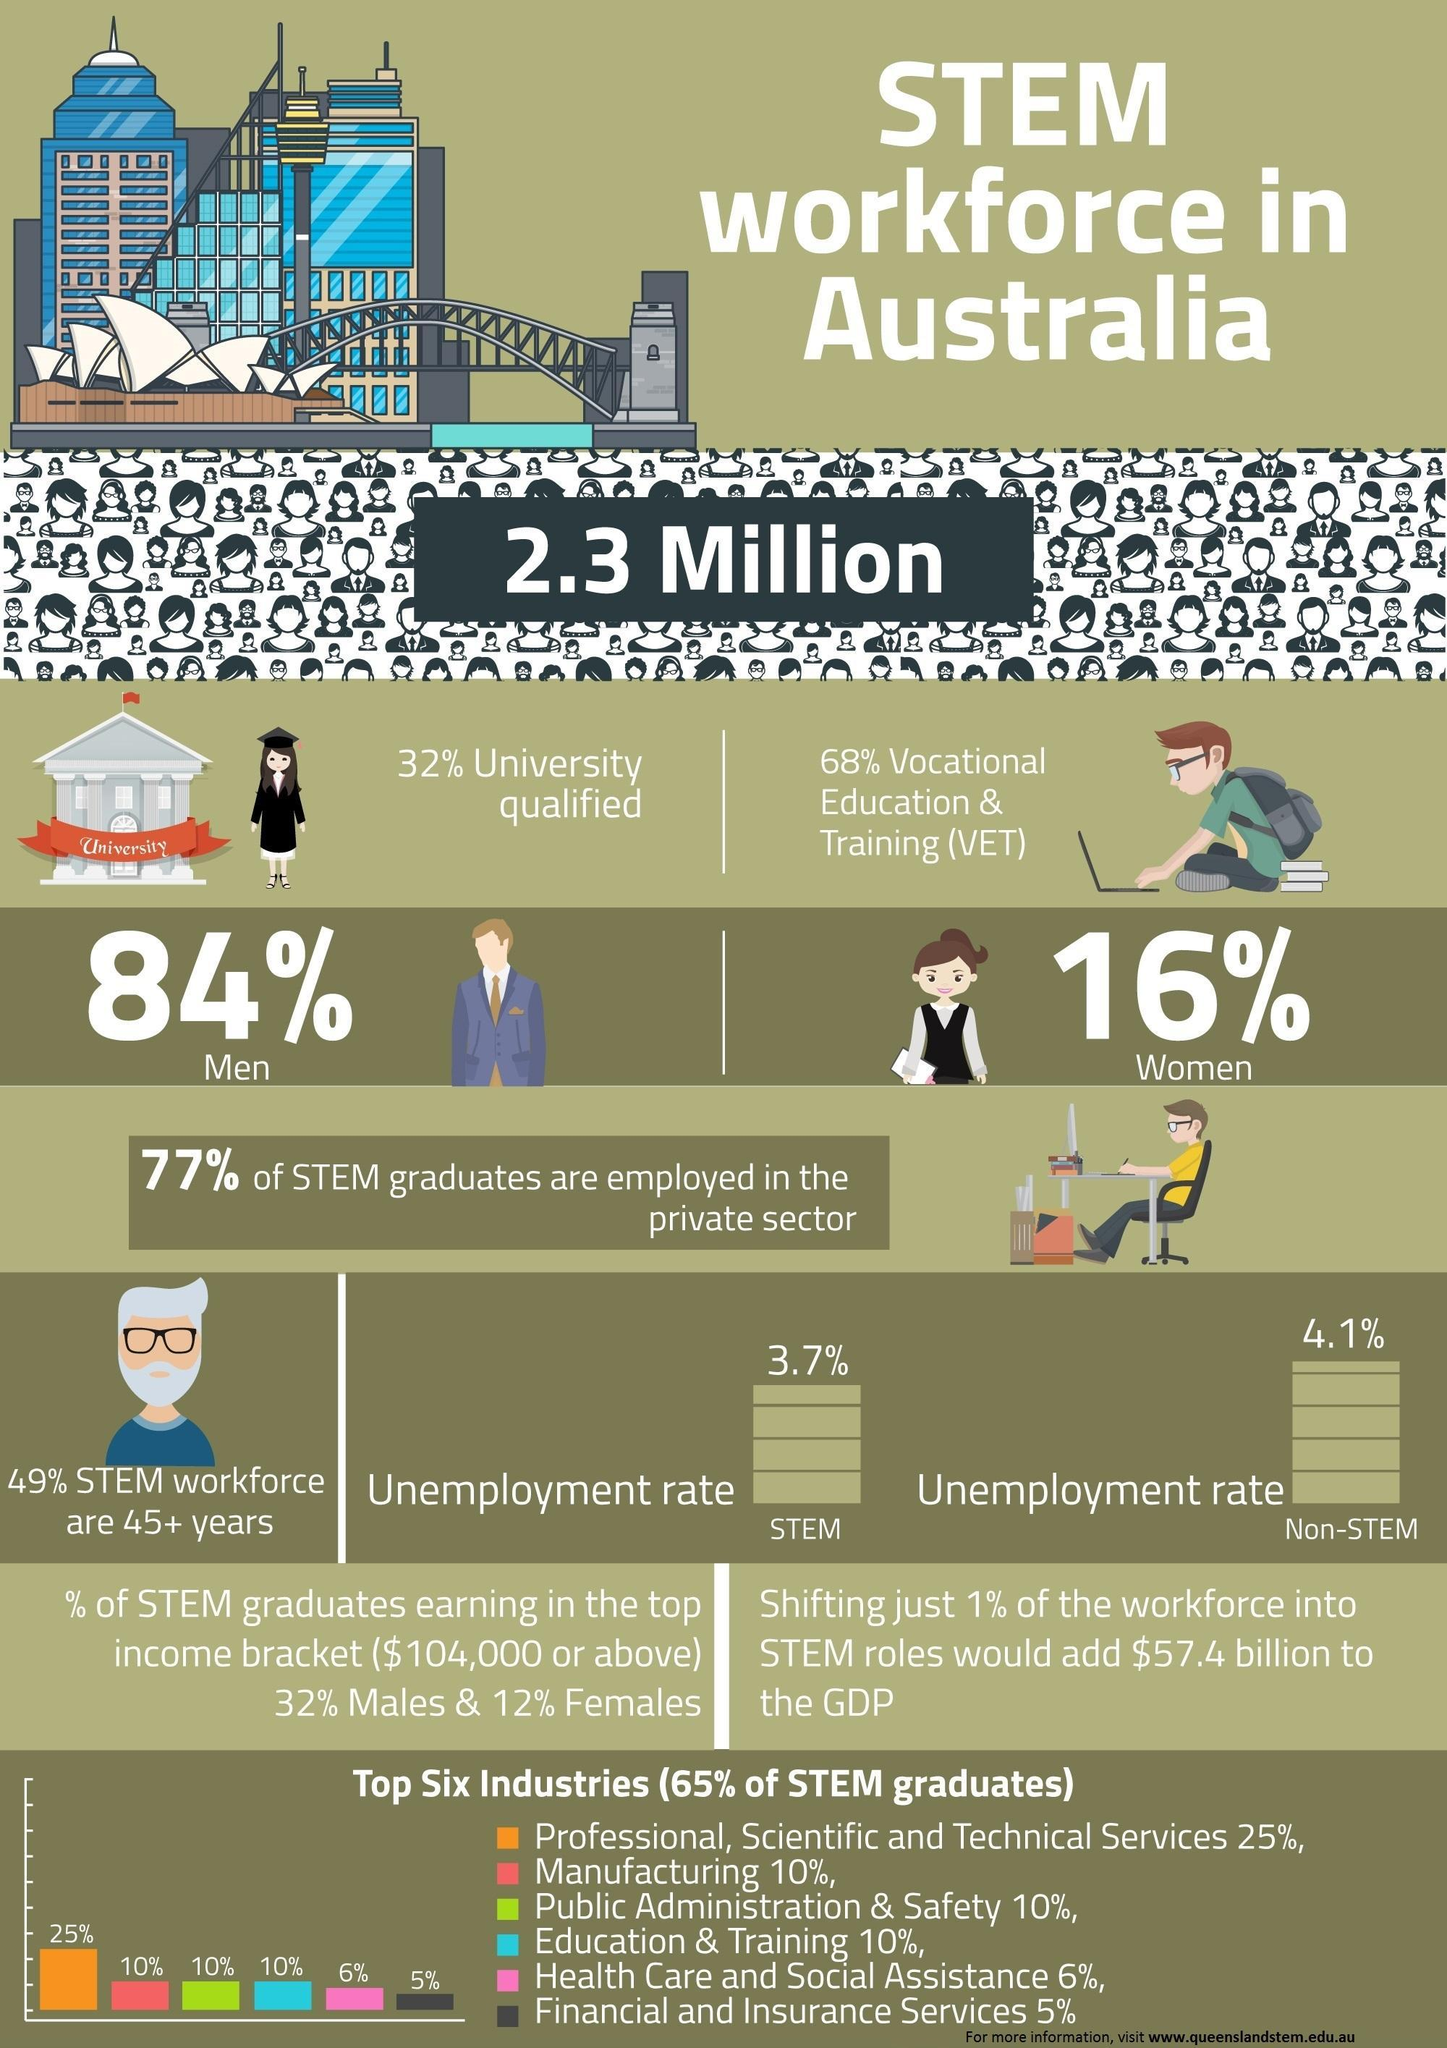What is the unemployment rate of of stem workforce in Australia?
Answer the question with a short phrase. 3.7% What percentage of stem workforce in Australia are women? 16% What is the unemployment rate of of non-stem workforce in Australia? 4.1% What percentage of stem graduates in Australia are from Financial & Insurance Services? 5% What percentage of the stem graduates are not employed in the private sector of Australia? 23% What percentage of stem workforce in Australia are men? 84% What percentage of stem graduates in Australia are from manufacturing industry? 10% 